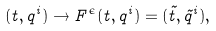<formula> <loc_0><loc_0><loc_500><loc_500>( t , q ^ { i } ) \rightarrow F ^ { \epsilon } ( t , q ^ { i } ) = ( \tilde { t } , \tilde { q } ^ { i } ) ,</formula> 